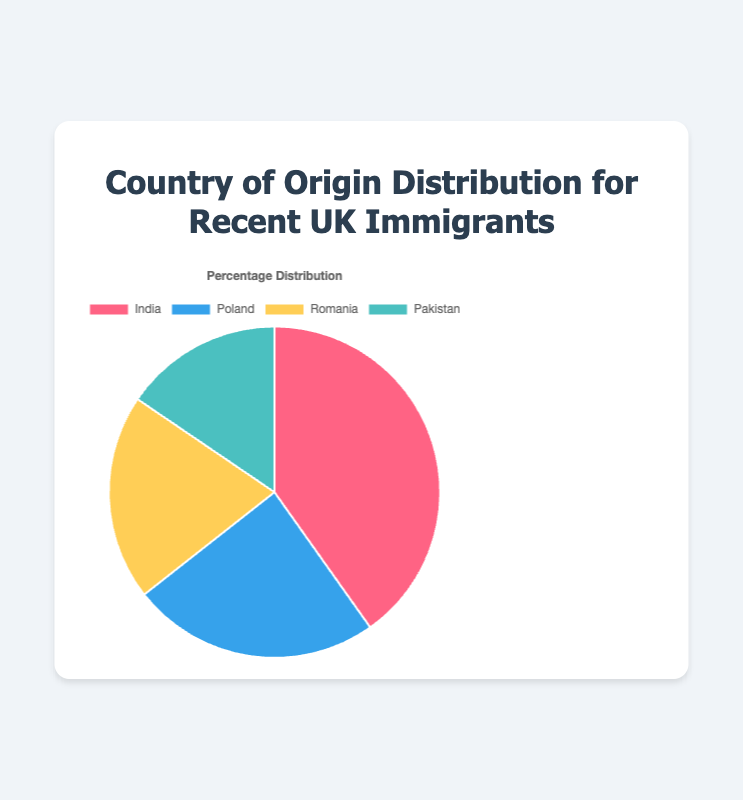What country of origin has the largest percentage of recent immigrants to the UK? By looking at the pie chart, we can see that the country with the largest section is India. The percentage label on this section shows 25.4%.
Answer: India Which country of origin has a larger percentage of recent immigrants, Romania or Pakistan? By comparing the sections for Romania and Pakistan, we see that Romania has 12.7% and Pakistan has 9.8%. Therefore, Romania has a larger percentage.
Answer: Romania What is the combined percentage of recent immigrants from Poland and Pakistan? The percentage for Poland is 15.3% and for Pakistan is 9.8%. Adding these together, 15.3% + 9.8% = 25.1%.
Answer: 25.1% How much higher is the percentage of recent immigrants from India compared to Romania? The percentage for India is 25.4% and for Romania is 12.7%. Subtracting the two, 25.4% - 12.7% = 12.7%.
Answer: 12.7% Which two countries have the smallest percentages of recent immigrants? From the pie chart, the sections with the smallest percentages are Pakistan with 9.8% and Romania with 12.7%.
Answer: Pakistan and Romania What is the average percentage of recent immigrants from the four countries? To find the average, add the percentages and divide by 4: (25.4% + 15.3% + 12.7% + 9.8%) / 4 = 63.2% / 4 = 15.8%.
Answer: 15.8% What percentage of recent immigrants are from non-Asian countries among the four given countries? Poland and Romania are non-Asian countries. Adding their percentages, 15.3% + 12.7% = 28%.
Answer: 28% What is the difference in percentage between the country with the highest and the country with the lowest recent immigrants? The highest is India with 25.4% and the lowest is Pakistan with 9.8%. The difference is 25.4% - 9.8% = 15.6%.
Answer: 15.6% Which section of the pie chart has the color associated with Romania? According to the visual properties visible in the pie chart, Romania is represented by the yellow section.
Answer: Yellow 